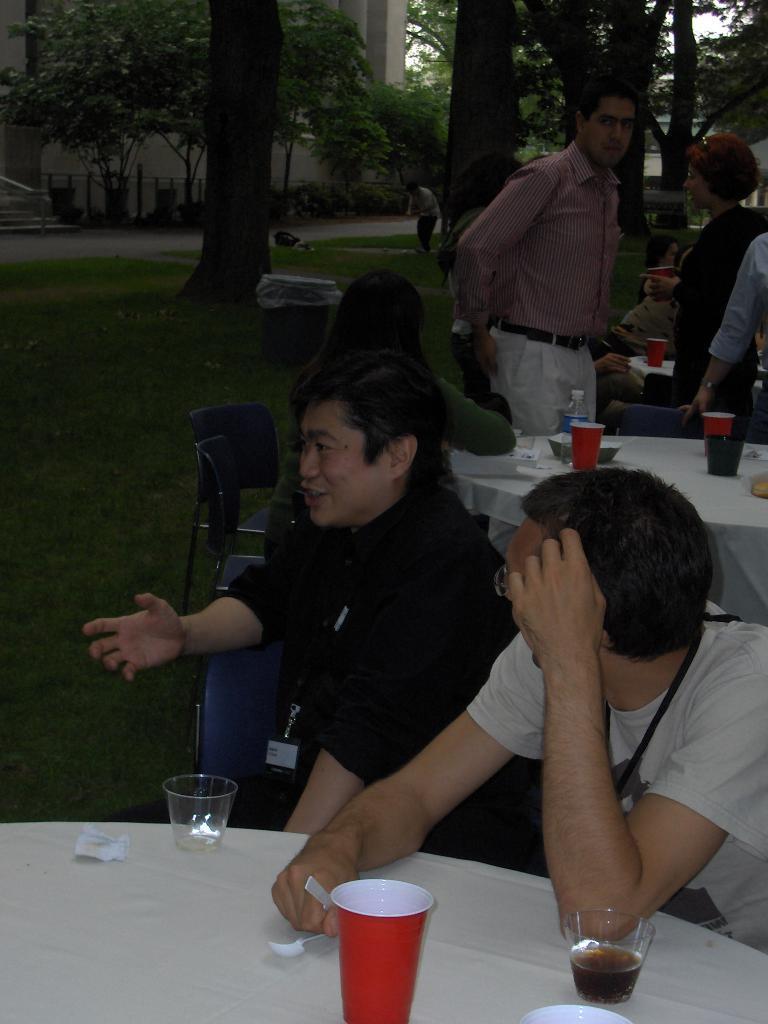Describe this image in one or two sentences. In this image we can see this people are sitting on chairs around table. There are cups, glasses and bottles on table. In the background we can see building and trees. 